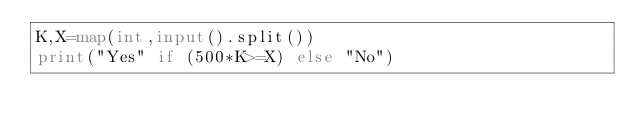Convert code to text. <code><loc_0><loc_0><loc_500><loc_500><_Python_>K,X=map(int,input().split())
print("Yes" if (500*K>=X) else "No")</code> 